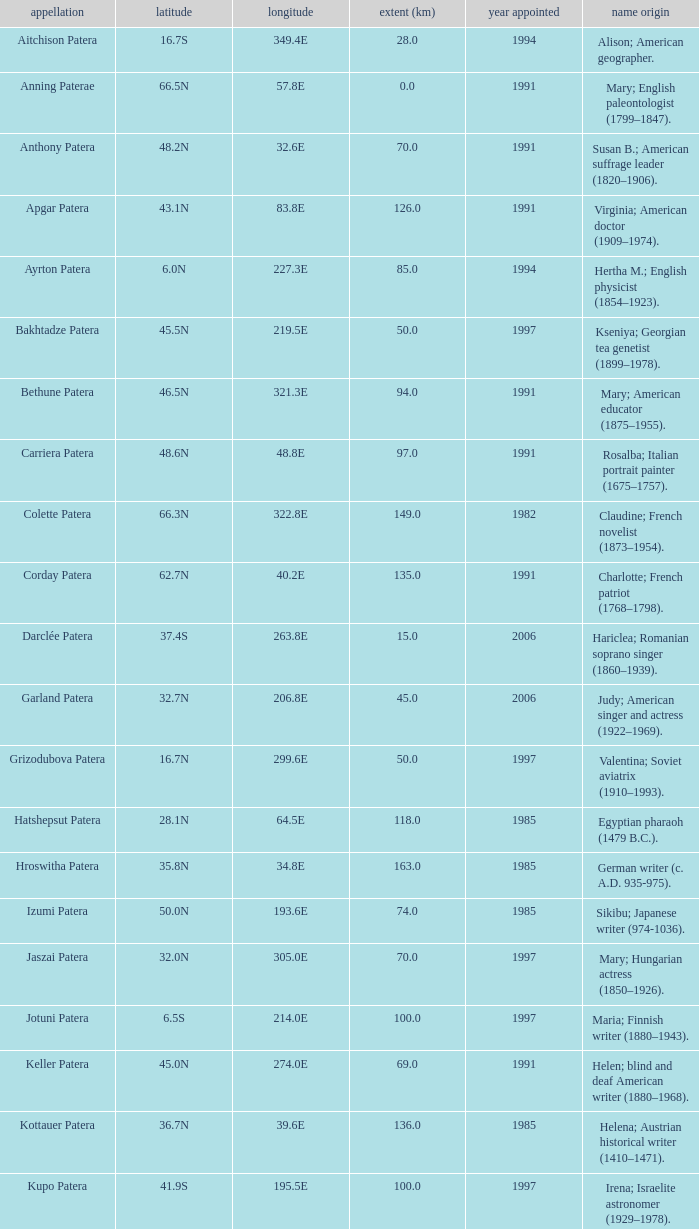Could you parse the entire table? {'header': ['appellation', 'latitude', 'longitude', 'extent (km)', 'year appointed', 'name origin'], 'rows': [['Aitchison Patera', '16.7S', '349.4E', '28.0', '1994', 'Alison; American geographer.'], ['Anning Paterae', '66.5N', '57.8E', '0.0', '1991', 'Mary; English paleontologist (1799–1847).'], ['Anthony Patera', '48.2N', '32.6E', '70.0', '1991', 'Susan B.; American suffrage leader (1820–1906).'], ['Apgar Patera', '43.1N', '83.8E', '126.0', '1991', 'Virginia; American doctor (1909–1974).'], ['Ayrton Patera', '6.0N', '227.3E', '85.0', '1994', 'Hertha M.; English physicist (1854–1923).'], ['Bakhtadze Patera', '45.5N', '219.5E', '50.0', '1997', 'Kseniya; Georgian tea genetist (1899–1978).'], ['Bethune Patera', '46.5N', '321.3E', '94.0', '1991', 'Mary; American educator (1875–1955).'], ['Carriera Patera', '48.6N', '48.8E', '97.0', '1991', 'Rosalba; Italian portrait painter (1675–1757).'], ['Colette Patera', '66.3N', '322.8E', '149.0', '1982', 'Claudine; French novelist (1873–1954).'], ['Corday Patera', '62.7N', '40.2E', '135.0', '1991', 'Charlotte; French patriot (1768–1798).'], ['Darclée Patera', '37.4S', '263.8E', '15.0', '2006', 'Hariclea; Romanian soprano singer (1860–1939).'], ['Garland Patera', '32.7N', '206.8E', '45.0', '2006', 'Judy; American singer and actress (1922–1969).'], ['Grizodubova Patera', '16.7N', '299.6E', '50.0', '1997', 'Valentina; Soviet aviatrix (1910–1993).'], ['Hatshepsut Patera', '28.1N', '64.5E', '118.0', '1985', 'Egyptian pharaoh (1479 B.C.).'], ['Hroswitha Patera', '35.8N', '34.8E', '163.0', '1985', 'German writer (c. A.D. 935-975).'], ['Izumi Patera', '50.0N', '193.6E', '74.0', '1985', 'Sikibu; Japanese writer (974-1036).'], ['Jaszai Patera', '32.0N', '305.0E', '70.0', '1997', 'Mary; Hungarian actress (1850–1926).'], ['Jotuni Patera', '6.5S', '214.0E', '100.0', '1997', 'Maria; Finnish writer (1880–1943).'], ['Keller Patera', '45.0N', '274.0E', '69.0', '1991', 'Helen; blind and deaf American writer (1880–1968).'], ['Kottauer Patera', '36.7N', '39.6E', '136.0', '1985', 'Helena; Austrian historical writer (1410–1471).'], ['Kupo Patera', '41.9S', '195.5E', '100.0', '1997', 'Irena; Israelite astronomer (1929–1978).'], ['Ledoux Patera', '9.2S', '224.8E', '75.0', '1994', 'Jeanne; French artist (1767–1840).'], ['Lindgren Patera', '28.1N', '241.4E', '110.0', '2006', 'Astrid; Swedish author (1907–2002).'], ['Mehseti Patera', '16.0N', '311.0E', '60.0', '1997', 'Ganjevi; Azeri/Persian poet (c. 1050-c. 1100).'], ['Mezrina Patera', '33.3S', '68.8E', '60.0', '2000', 'Anna; Russian clay toy sculptor (1853–1938).'], ['Nordenflycht Patera', '35.0S', '266.0E', '140.0', '1997', 'Hedwig; Swedish poet (1718–1763).'], ['Panina Patera', '13.0S', '309.8E', '50.0', '1997', 'Varya; Gypsy/Russian singer (1872–1911).'], ['Payne-Gaposchkin Patera', '25.5S', '196.0E', '100.0', '1997', 'Cecilia Helena; American astronomer (1900–1979).'], ['Pocahontas Patera', '64.9N', '49.4E', '78.0', '1991', 'Powhatan Indian peacemaker (1595–1617).'], ['Raskova Paterae', '51.0S', '222.8E', '80.0', '1994', 'Marina M.; Russian aviator (1912–1943).'], ['Razia Patera', '46.2N', '197.8E', '157.0', '1985', 'Queen of Delhi Sultanate (India) (1236–1240).'], ['Shulzhenko Patera', '6.5N', '264.5E', '60.0', '1997', 'Klavdiya; Soviet singer (1906–1984).'], ['Siddons Patera', '61.6N', '340.6E', '47.0', '1997', 'Sarah; English actress (1755–1831).'], ['Stopes Patera', '42.6N', '46.5E', '169.0', '1991', 'Marie; English paleontologist (1880–1959).'], ['Tarbell Patera', '58.2S', '351.5E', '80.0', '1994', 'Ida; American author, editor (1857–1944).'], ['Teasdale Patera', '67.6S', '189.1E', '75.0', '1994', 'Sara; American poet (1884–1933).'], ['Tey Patera', '17.8S', '349.1E', '20.0', '1994', 'Josephine; Scottish author (1897–1952).'], ['Tipporah Patera', '38.9N', '43.0E', '99.0', '1985', 'Hebrew medical scholar (1500 B.C.).'], ['Vibert-Douglas Patera', '11.6S', '194.3E', '45.0', '2003', 'Allie; Canadian astronomer (1894–1988).'], ['Villepreux-Power Patera', '22.0S', '210.0E', '100.0', '1997', 'Jeannette; French marine biologist (1794–1871).'], ['Wilde Patera', '21.3S', '266.3E', '75.0', '2000', 'Lady Jane Francesca; Irish poet (1821–1891).'], ['Witte Patera', '25.8S', '247.65E', '35.0', '2006', 'Wilhelmine; German astronomer (1777–1854).'], ['Woodhull Patera', '37.4N', '305.4E', '83.0', '1991', 'Victoria; American-English lecturer (1838–1927).']]} What is the longitude of the feature named Razia Patera?  197.8E. 